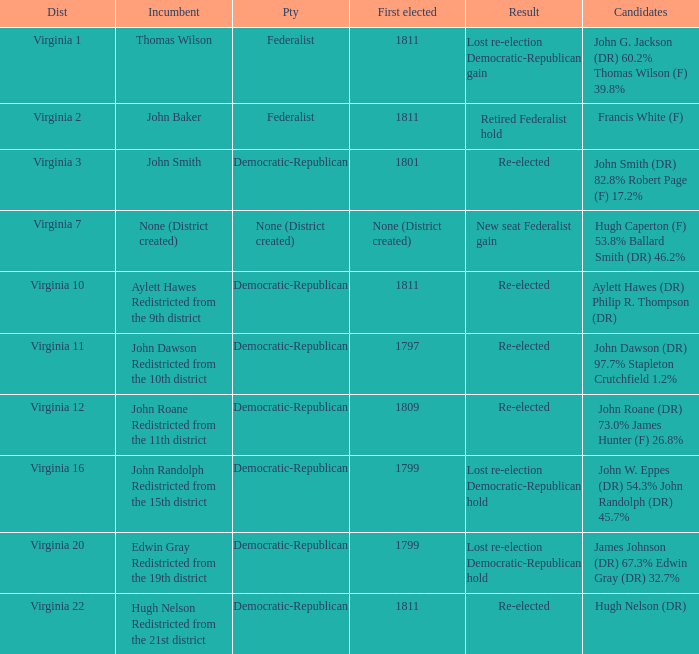Name the distrct for thomas wilson Virginia 1. 